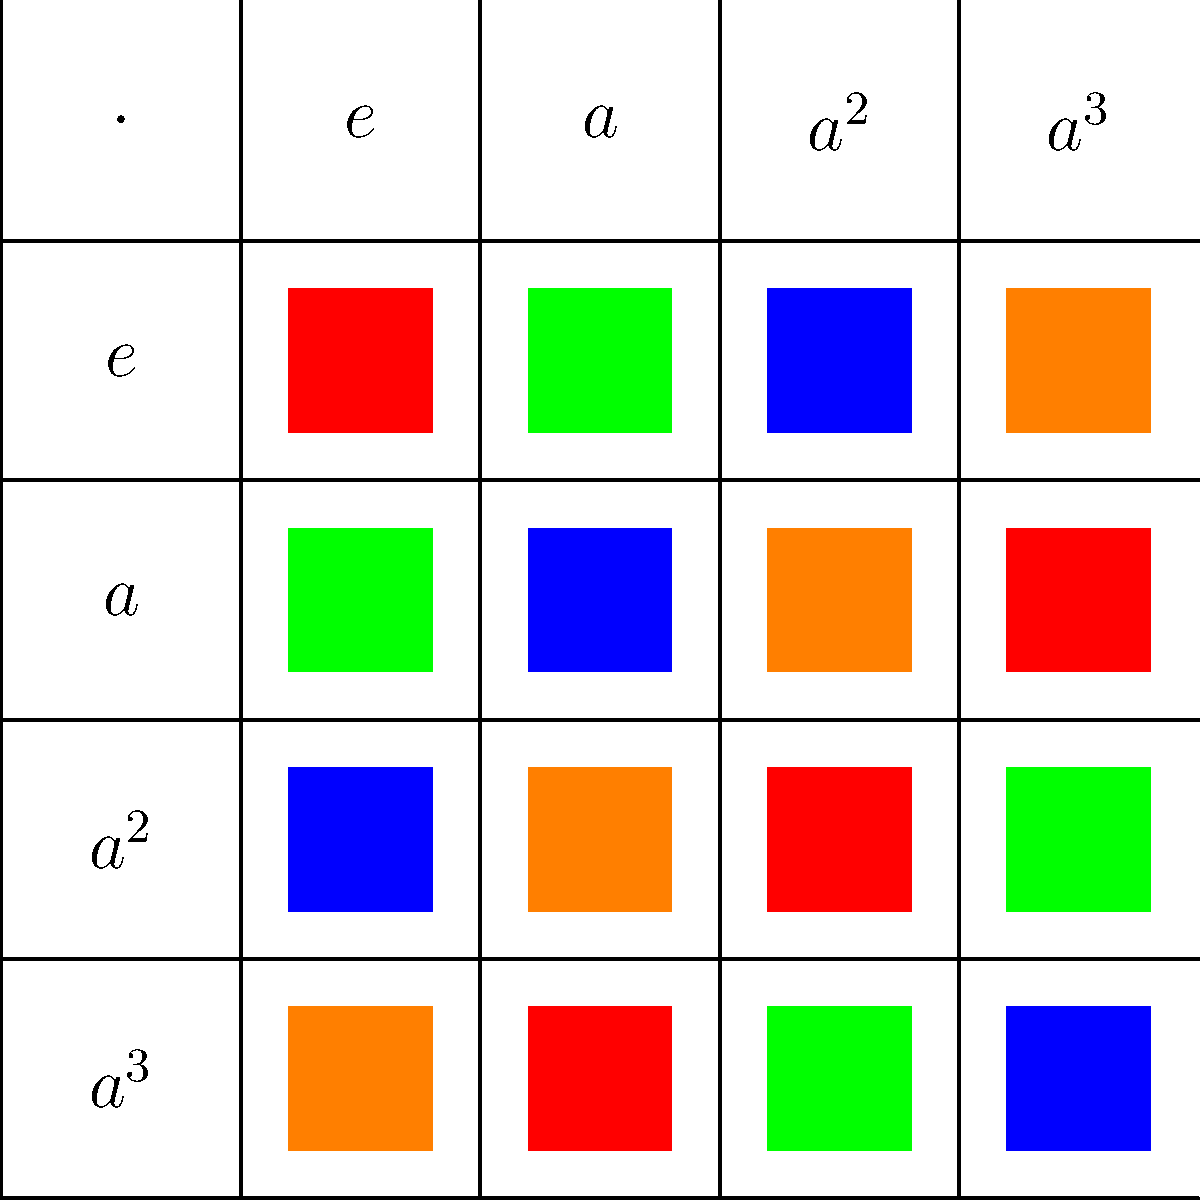In the context of group theory, analyze the Cayley table shown above for a cyclic group of order 4. Which element serves as the generator for this group, and how many times must it be applied to itself to generate all elements of the group? Let's approach this step-by-step:

1. First, we need to identify the elements of the group. From the Cayley table, we can see that the group has four elements: $e$, $a$, $a^2$, and $a^3$.

2. The element $e$ is the identity element, as multiplying any element by $e$ results in that element itself.

3. To determine the generator, we need to find an element that, when repeatedly applied to itself, generates all other elements of the group.

4. Let's start with $a$:
   - $a^1 = a$
   - $a^2$ is given
   - $a^3$ is given
   - $a^4 = e$ (because $a \cdot a^3 = e$ in the table)

5. We can see that starting with $a$ and repeatedly multiplying by $a$, we generate all elements of the group:
   $a \to a^2 \to a^3 \to e$

6. This cycle repeats after reaching $e$, confirming that the group is indeed cyclic.

7. The number of times $a$ needs to be applied to itself to generate all elements is 4, which is equal to the order of the group.

Therefore, $a$ is the generator of this cyclic group, and it needs to be applied 4 times to generate all elements of the group.
Answer: $a$; 4 times 